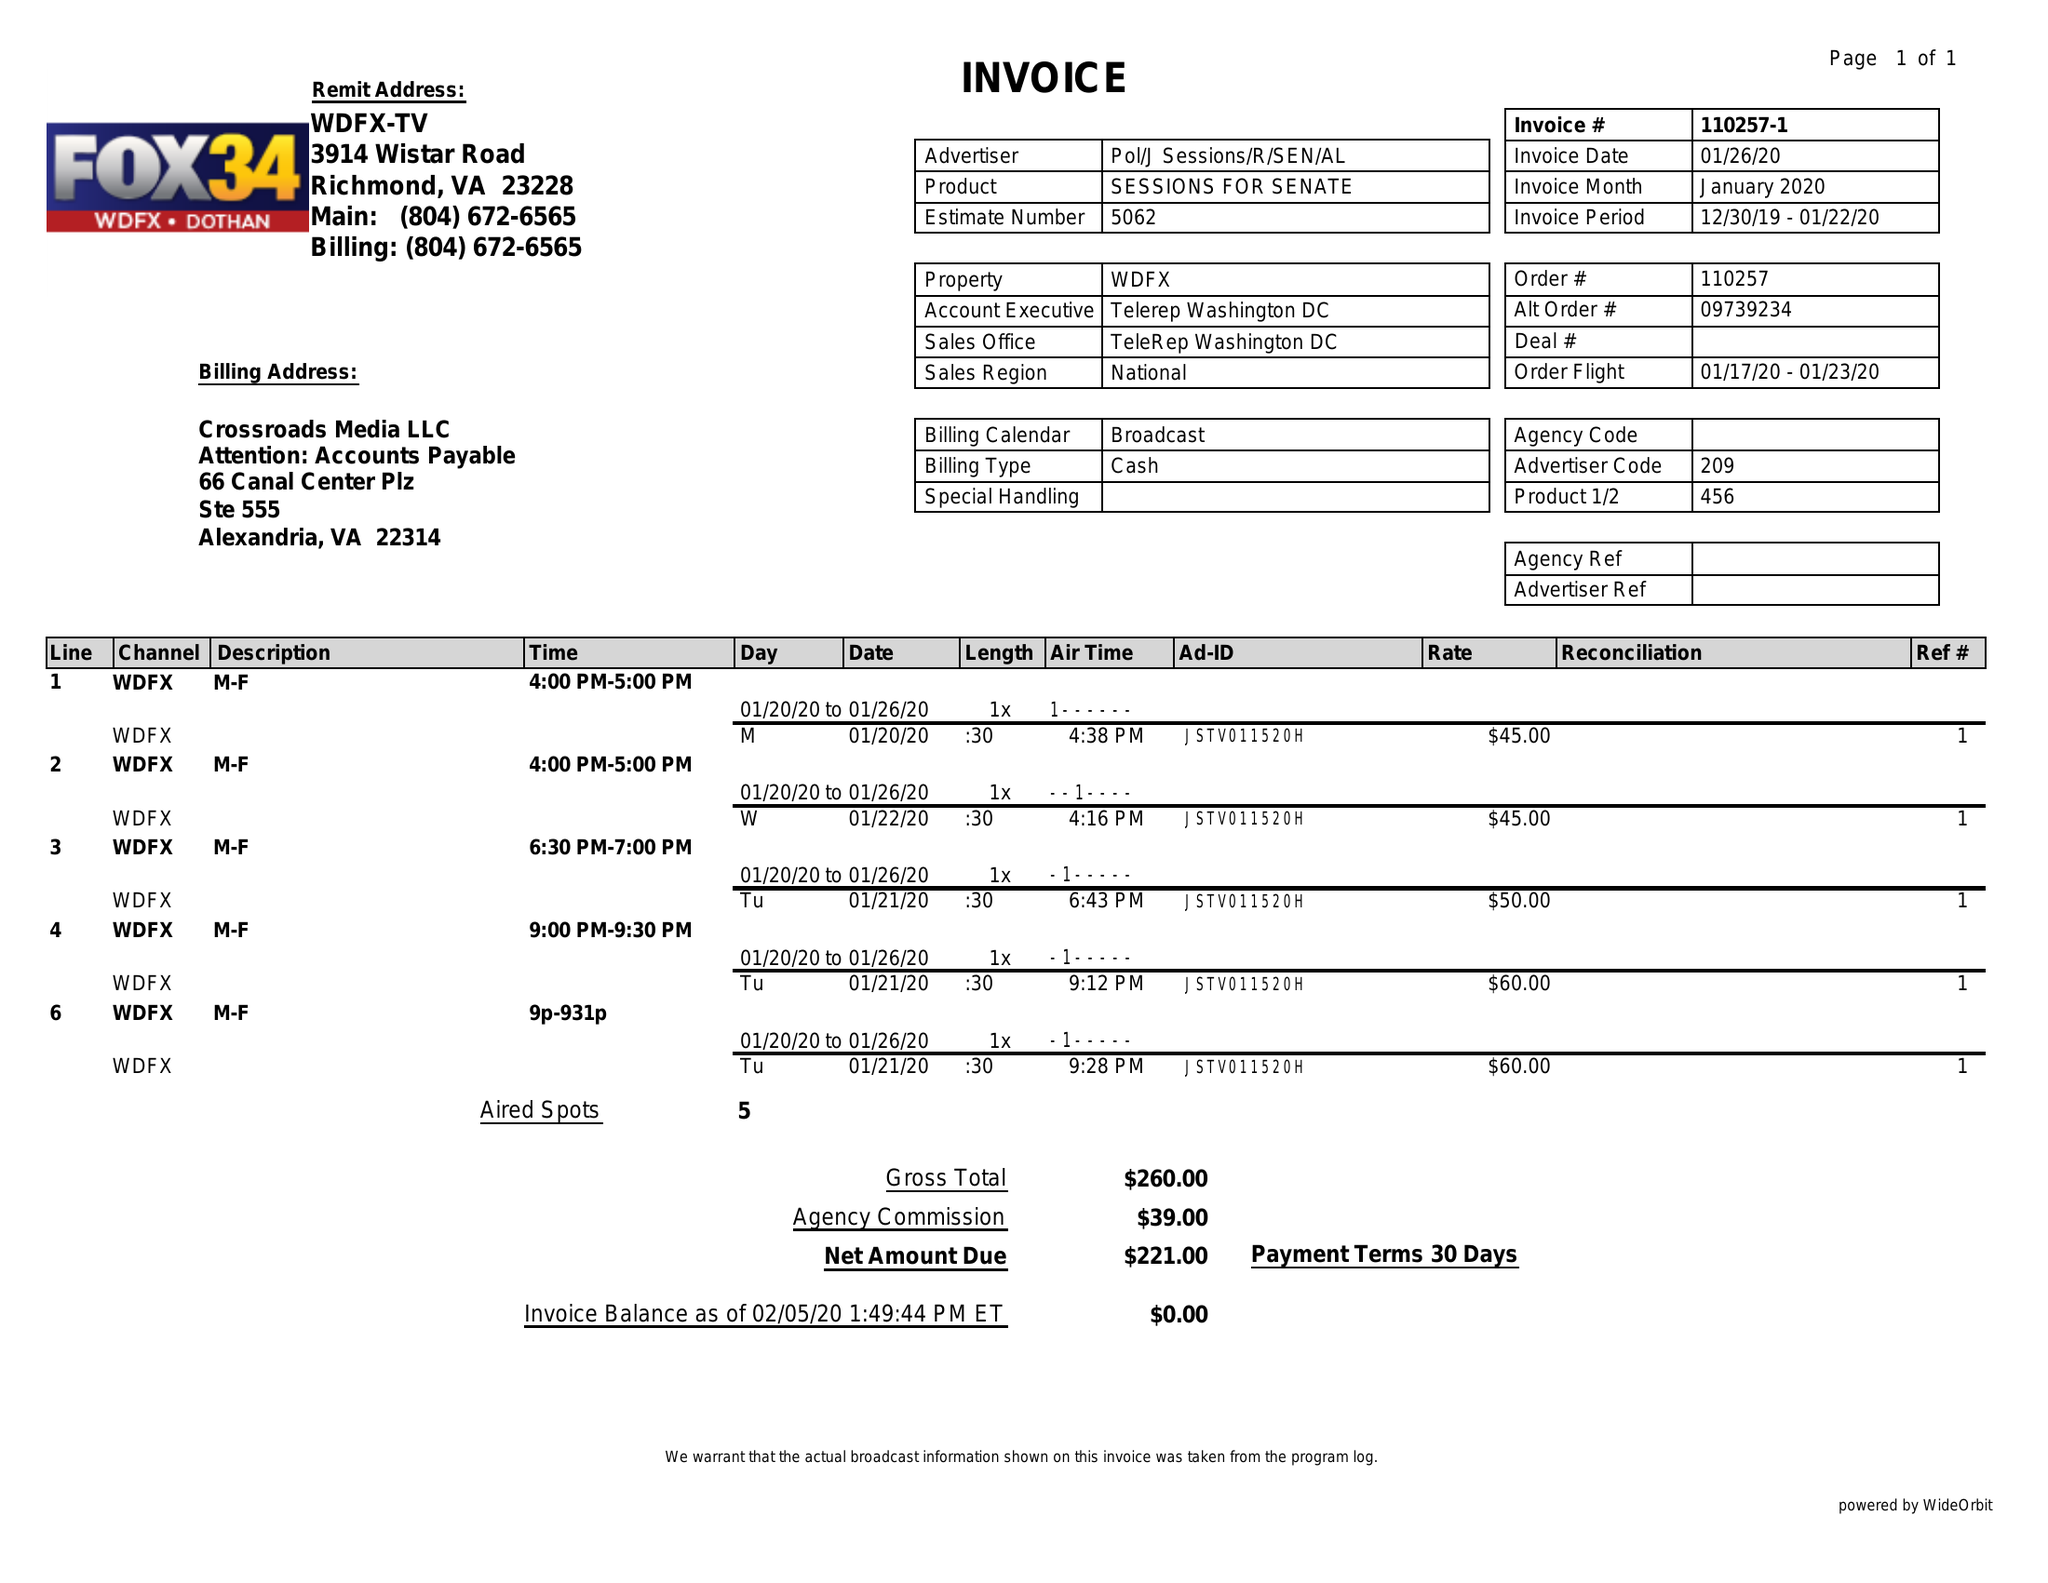What is the value for the contract_num?
Answer the question using a single word or phrase. 110257 